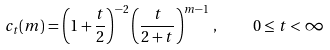Convert formula to latex. <formula><loc_0><loc_0><loc_500><loc_500>c _ { t } ( m ) = \left ( 1 + \frac { t } { 2 } \right ) ^ { - 2 } \left ( \frac { t } { 2 + t } \right ) ^ { m - 1 } \, , \quad 0 \leq t < \infty</formula> 